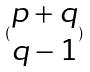<formula> <loc_0><loc_0><loc_500><loc_500>( \begin{matrix} p + q \\ q - 1 \end{matrix} )</formula> 